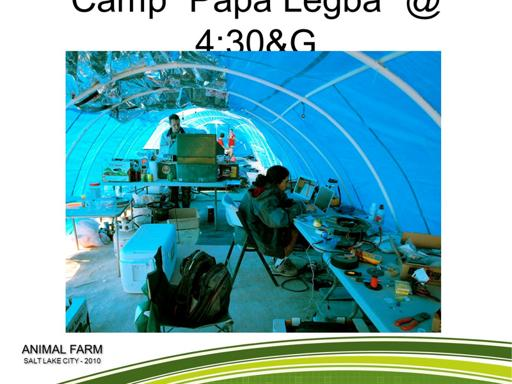Can you describe what the people in the image are doing? The individuals in the image are engaged in technical activities, possibly assembling or configuring electronic devices or machinery. The setting suggests a collaborative workspace likely focused on innovation or technological development. 